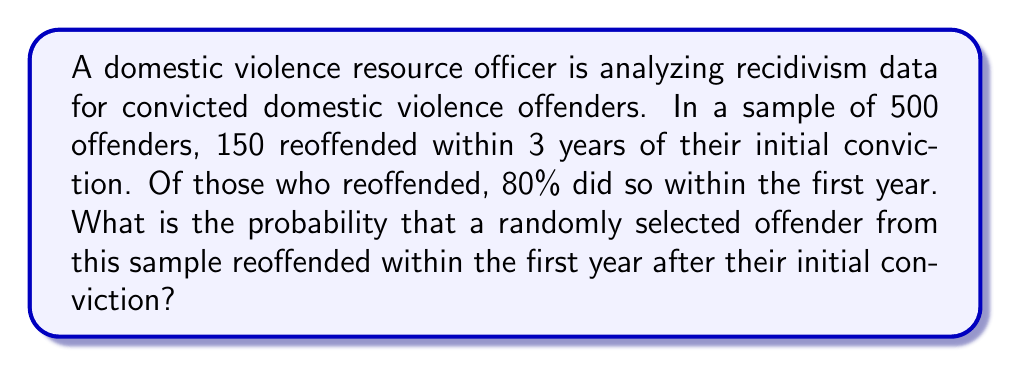Solve this math problem. To solve this problem, we need to use the concept of conditional probability and the given information:

1. Total number of offenders in the sample: $N = 500$
2. Number of offenders who reoffended within 3 years: $R = 150$
3. Percentage of reoffenders who did so within the first year: $80\% = 0.80$

Let's break down the solution:

1. Calculate the probability of reoffending within 3 years:
   $$P(\text{reoffend within 3 years}) = \frac{R}{N} = \frac{150}{500} = 0.30$$

2. Calculate the number of offenders who reoffended within the first year:
   $$\text{Reoffended within 1st year} = 80\% \text{ of } R = 0.80 \times 150 = 120$$

3. Calculate the probability of reoffending within the first year:
   $$P(\text{reoffend within 1st year}) = \frac{\text{Reoffended within 1st year}}{N} = \frac{120}{500} = 0.24$$

Therefore, the probability that a randomly selected offender from this sample reoffended within the first year after their initial conviction is 0.24 or 24%.
Answer: 0.24 or 24% 